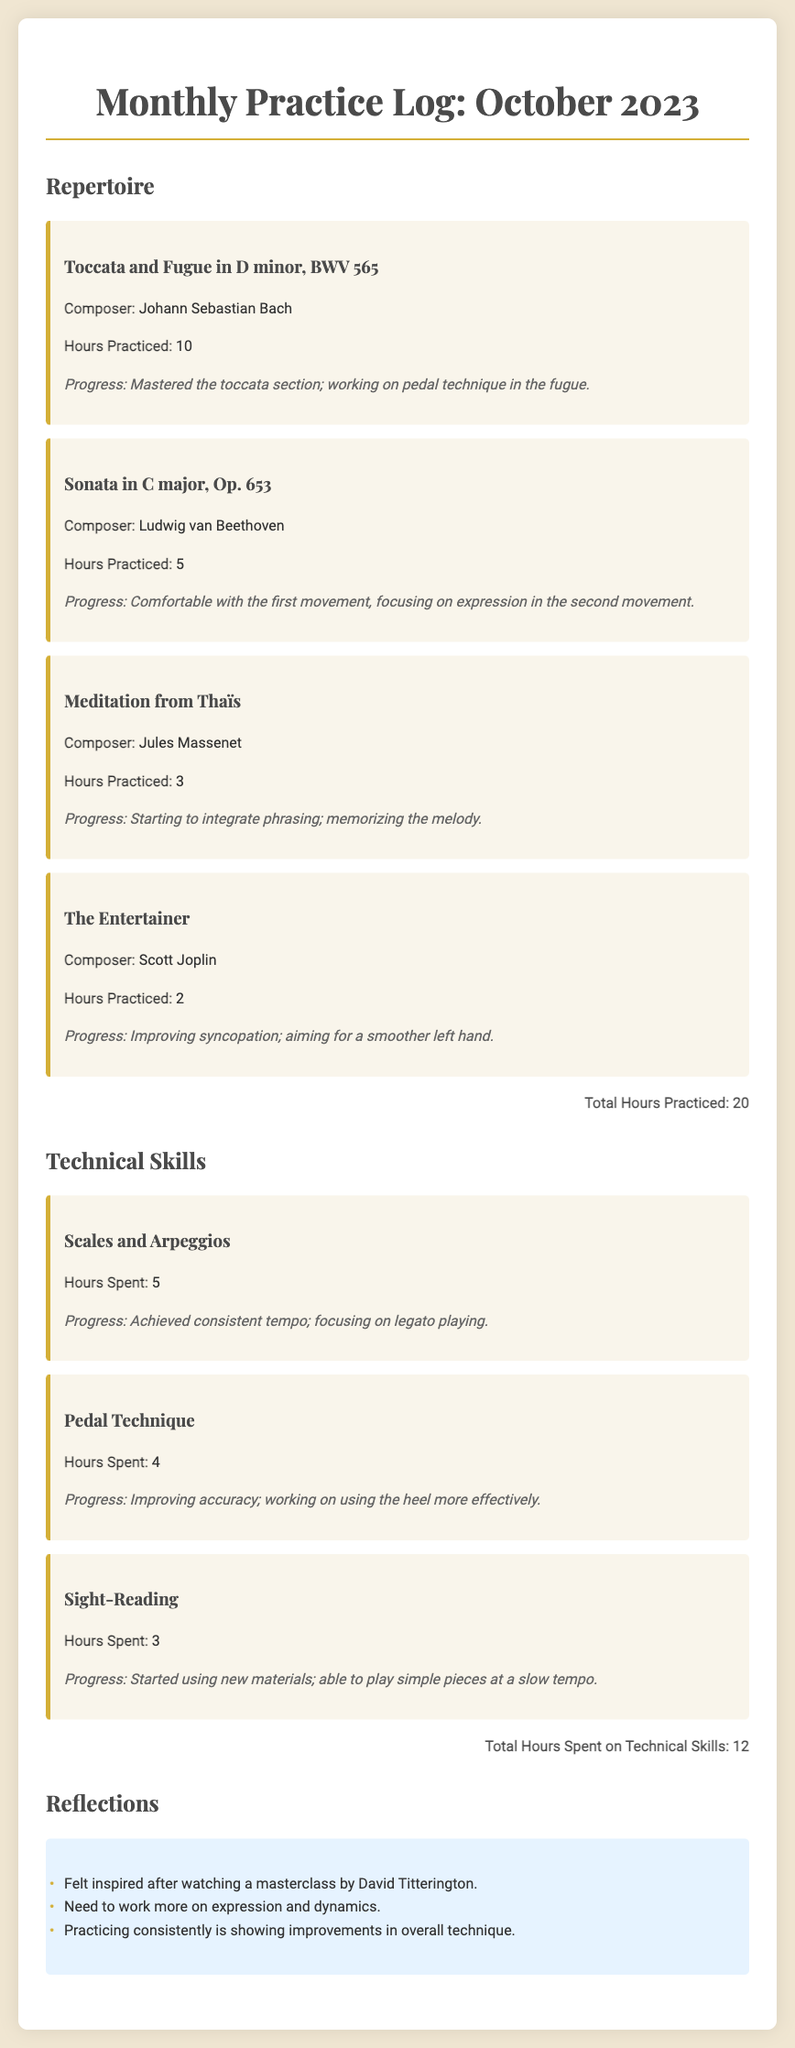What is the total hours practiced for October 2023? The total hours practiced is the sum of hours practiced for each repertoire item in the document: 10 + 5 + 3 + 2 = 20 hours.
Answer: 20 Who is the composer of "Toccata and Fugue in D minor, BWV 565"? The document specifies that "Toccata and Fugue in D minor, BWV 565" is composed by Johann Sebastian Bach.
Answer: Johann Sebastian Bach What technical skill had the most hours spent? The document lists the hours spent on each technical skill, and "Scales and Arpeggios" has the highest total at 5 hours.
Answer: Scales and Arpeggios What progress is made on "Meditation from Thaïs"? The document outlines the progress for each repertoire item; for "Meditation from Thaïs," it states that the focus is on integrating phrasing and memorizing the melody.
Answer: Starting to integrate phrasing; memorizing the melody How many total hours were spent on technical skills? The document sums hours spent on all technical skills, which are 5 + 4 + 3 = 12 hours.
Answer: 12 